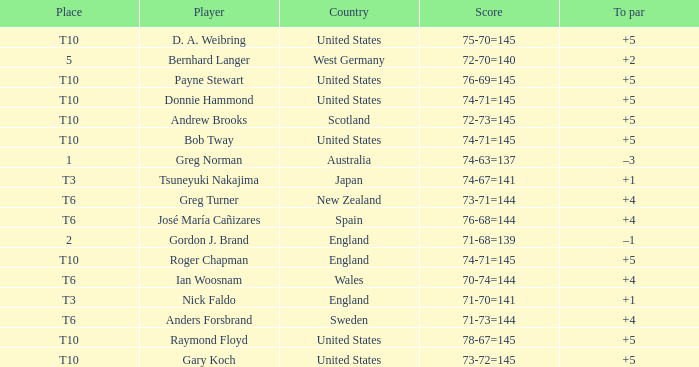Which player scored 76-68=144? José María Cañizares. Could you help me parse every detail presented in this table? {'header': ['Place', 'Player', 'Country', 'Score', 'To par'], 'rows': [['T10', 'D. A. Weibring', 'United States', '75-70=145', '+5'], ['5', 'Bernhard Langer', 'West Germany', '72-70=140', '+2'], ['T10', 'Payne Stewart', 'United States', '76-69=145', '+5'], ['T10', 'Donnie Hammond', 'United States', '74-71=145', '+5'], ['T10', 'Andrew Brooks', 'Scotland', '72-73=145', '+5'], ['T10', 'Bob Tway', 'United States', '74-71=145', '+5'], ['1', 'Greg Norman', 'Australia', '74-63=137', '–3'], ['T3', 'Tsuneyuki Nakajima', 'Japan', '74-67=141', '+1'], ['T6', 'Greg Turner', 'New Zealand', '73-71=144', '+4'], ['T6', 'José María Cañizares', 'Spain', '76-68=144', '+4'], ['2', 'Gordon J. Brand', 'England', '71-68=139', '–1'], ['T10', 'Roger Chapman', 'England', '74-71=145', '+5'], ['T6', 'Ian Woosnam', 'Wales', '70-74=144', '+4'], ['T3', 'Nick Faldo', 'England', '71-70=141', '+1'], ['T6', 'Anders Forsbrand', 'Sweden', '71-73=144', '+4'], ['T10', 'Raymond Floyd', 'United States', '78-67=145', '+5'], ['T10', 'Gary Koch', 'United States', '73-72=145', '+5']]} 